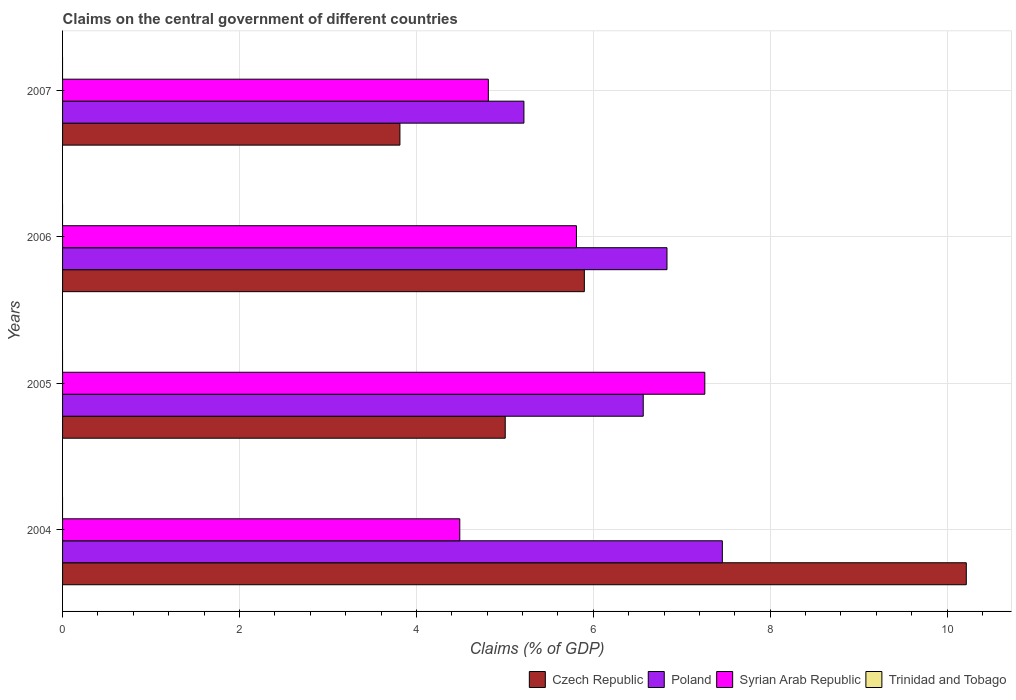How many different coloured bars are there?
Ensure brevity in your answer.  3. What is the label of the 2nd group of bars from the top?
Your answer should be compact. 2006. In how many cases, is the number of bars for a given year not equal to the number of legend labels?
Provide a short and direct response. 4. What is the percentage of GDP claimed on the central government in Trinidad and Tobago in 2007?
Ensure brevity in your answer.  0. Across all years, what is the maximum percentage of GDP claimed on the central government in Poland?
Your response must be concise. 7.46. Across all years, what is the minimum percentage of GDP claimed on the central government in Syrian Arab Republic?
Give a very brief answer. 4.49. In which year was the percentage of GDP claimed on the central government in Syrian Arab Republic maximum?
Make the answer very short. 2005. What is the total percentage of GDP claimed on the central government in Poland in the graph?
Ensure brevity in your answer.  26.07. What is the difference between the percentage of GDP claimed on the central government in Syrian Arab Republic in 2006 and that in 2007?
Offer a terse response. 1. What is the difference between the percentage of GDP claimed on the central government in Syrian Arab Republic in 2005 and the percentage of GDP claimed on the central government in Poland in 2007?
Give a very brief answer. 2.04. What is the average percentage of GDP claimed on the central government in Syrian Arab Republic per year?
Offer a very short reply. 5.59. In the year 2005, what is the difference between the percentage of GDP claimed on the central government in Czech Republic and percentage of GDP claimed on the central government in Syrian Arab Republic?
Keep it short and to the point. -2.26. In how many years, is the percentage of GDP claimed on the central government in Trinidad and Tobago greater than 9.2 %?
Your response must be concise. 0. What is the ratio of the percentage of GDP claimed on the central government in Czech Republic in 2005 to that in 2007?
Your response must be concise. 1.31. Is the percentage of GDP claimed on the central government in Poland in 2006 less than that in 2007?
Offer a terse response. No. Is the difference between the percentage of GDP claimed on the central government in Czech Republic in 2004 and 2005 greater than the difference between the percentage of GDP claimed on the central government in Syrian Arab Republic in 2004 and 2005?
Your answer should be very brief. Yes. What is the difference between the highest and the second highest percentage of GDP claimed on the central government in Czech Republic?
Your answer should be very brief. 4.32. What is the difference between the highest and the lowest percentage of GDP claimed on the central government in Syrian Arab Republic?
Your answer should be very brief. 2.77. In how many years, is the percentage of GDP claimed on the central government in Trinidad and Tobago greater than the average percentage of GDP claimed on the central government in Trinidad and Tobago taken over all years?
Offer a very short reply. 0. Is the sum of the percentage of GDP claimed on the central government in Syrian Arab Republic in 2005 and 2007 greater than the maximum percentage of GDP claimed on the central government in Trinidad and Tobago across all years?
Offer a terse response. Yes. Is it the case that in every year, the sum of the percentage of GDP claimed on the central government in Poland and percentage of GDP claimed on the central government in Syrian Arab Republic is greater than the sum of percentage of GDP claimed on the central government in Czech Republic and percentage of GDP claimed on the central government in Trinidad and Tobago?
Provide a short and direct response. No. Is it the case that in every year, the sum of the percentage of GDP claimed on the central government in Czech Republic and percentage of GDP claimed on the central government in Trinidad and Tobago is greater than the percentage of GDP claimed on the central government in Syrian Arab Republic?
Provide a succinct answer. No. How many bars are there?
Your answer should be very brief. 12. Are the values on the major ticks of X-axis written in scientific E-notation?
Ensure brevity in your answer.  No. Where does the legend appear in the graph?
Offer a very short reply. Bottom right. How many legend labels are there?
Offer a terse response. 4. How are the legend labels stacked?
Ensure brevity in your answer.  Horizontal. What is the title of the graph?
Make the answer very short. Claims on the central government of different countries. What is the label or title of the X-axis?
Provide a short and direct response. Claims (% of GDP). What is the Claims (% of GDP) of Czech Republic in 2004?
Your answer should be compact. 10.22. What is the Claims (% of GDP) of Poland in 2004?
Your answer should be very brief. 7.46. What is the Claims (% of GDP) in Syrian Arab Republic in 2004?
Your answer should be very brief. 4.49. What is the Claims (% of GDP) of Czech Republic in 2005?
Keep it short and to the point. 5. What is the Claims (% of GDP) of Poland in 2005?
Make the answer very short. 6.56. What is the Claims (% of GDP) of Syrian Arab Republic in 2005?
Make the answer very short. 7.26. What is the Claims (% of GDP) in Czech Republic in 2006?
Provide a short and direct response. 5.9. What is the Claims (% of GDP) in Poland in 2006?
Keep it short and to the point. 6.83. What is the Claims (% of GDP) in Syrian Arab Republic in 2006?
Your response must be concise. 5.81. What is the Claims (% of GDP) in Czech Republic in 2007?
Keep it short and to the point. 3.81. What is the Claims (% of GDP) in Poland in 2007?
Provide a succinct answer. 5.22. What is the Claims (% of GDP) of Syrian Arab Republic in 2007?
Your answer should be compact. 4.81. What is the Claims (% of GDP) of Trinidad and Tobago in 2007?
Your answer should be compact. 0. Across all years, what is the maximum Claims (% of GDP) of Czech Republic?
Make the answer very short. 10.22. Across all years, what is the maximum Claims (% of GDP) of Poland?
Offer a terse response. 7.46. Across all years, what is the maximum Claims (% of GDP) in Syrian Arab Republic?
Keep it short and to the point. 7.26. Across all years, what is the minimum Claims (% of GDP) of Czech Republic?
Offer a very short reply. 3.81. Across all years, what is the minimum Claims (% of GDP) of Poland?
Your answer should be very brief. 5.22. Across all years, what is the minimum Claims (% of GDP) in Syrian Arab Republic?
Offer a very short reply. 4.49. What is the total Claims (% of GDP) of Czech Republic in the graph?
Your answer should be compact. 24.93. What is the total Claims (% of GDP) in Poland in the graph?
Your answer should be compact. 26.07. What is the total Claims (% of GDP) in Syrian Arab Republic in the graph?
Provide a short and direct response. 22.37. What is the difference between the Claims (% of GDP) of Czech Republic in 2004 and that in 2005?
Your answer should be compact. 5.21. What is the difference between the Claims (% of GDP) of Poland in 2004 and that in 2005?
Provide a succinct answer. 0.89. What is the difference between the Claims (% of GDP) in Syrian Arab Republic in 2004 and that in 2005?
Offer a very short reply. -2.77. What is the difference between the Claims (% of GDP) in Czech Republic in 2004 and that in 2006?
Make the answer very short. 4.32. What is the difference between the Claims (% of GDP) in Poland in 2004 and that in 2006?
Offer a terse response. 0.63. What is the difference between the Claims (% of GDP) of Syrian Arab Republic in 2004 and that in 2006?
Make the answer very short. -1.32. What is the difference between the Claims (% of GDP) in Czech Republic in 2004 and that in 2007?
Provide a short and direct response. 6.4. What is the difference between the Claims (% of GDP) in Poland in 2004 and that in 2007?
Your answer should be very brief. 2.24. What is the difference between the Claims (% of GDP) in Syrian Arab Republic in 2004 and that in 2007?
Provide a short and direct response. -0.32. What is the difference between the Claims (% of GDP) of Czech Republic in 2005 and that in 2006?
Offer a terse response. -0.89. What is the difference between the Claims (% of GDP) in Poland in 2005 and that in 2006?
Keep it short and to the point. -0.27. What is the difference between the Claims (% of GDP) in Syrian Arab Republic in 2005 and that in 2006?
Ensure brevity in your answer.  1.45. What is the difference between the Claims (% of GDP) of Czech Republic in 2005 and that in 2007?
Make the answer very short. 1.19. What is the difference between the Claims (% of GDP) in Poland in 2005 and that in 2007?
Offer a very short reply. 1.35. What is the difference between the Claims (% of GDP) of Syrian Arab Republic in 2005 and that in 2007?
Make the answer very short. 2.45. What is the difference between the Claims (% of GDP) of Czech Republic in 2006 and that in 2007?
Offer a terse response. 2.08. What is the difference between the Claims (% of GDP) in Poland in 2006 and that in 2007?
Your answer should be compact. 1.62. What is the difference between the Claims (% of GDP) in Czech Republic in 2004 and the Claims (% of GDP) in Poland in 2005?
Your response must be concise. 3.65. What is the difference between the Claims (% of GDP) of Czech Republic in 2004 and the Claims (% of GDP) of Syrian Arab Republic in 2005?
Your answer should be very brief. 2.96. What is the difference between the Claims (% of GDP) in Poland in 2004 and the Claims (% of GDP) in Syrian Arab Republic in 2005?
Keep it short and to the point. 0.2. What is the difference between the Claims (% of GDP) of Czech Republic in 2004 and the Claims (% of GDP) of Poland in 2006?
Provide a short and direct response. 3.38. What is the difference between the Claims (% of GDP) in Czech Republic in 2004 and the Claims (% of GDP) in Syrian Arab Republic in 2006?
Keep it short and to the point. 4.41. What is the difference between the Claims (% of GDP) in Poland in 2004 and the Claims (% of GDP) in Syrian Arab Republic in 2006?
Ensure brevity in your answer.  1.65. What is the difference between the Claims (% of GDP) in Czech Republic in 2004 and the Claims (% of GDP) in Poland in 2007?
Make the answer very short. 5. What is the difference between the Claims (% of GDP) in Czech Republic in 2004 and the Claims (% of GDP) in Syrian Arab Republic in 2007?
Your answer should be compact. 5.4. What is the difference between the Claims (% of GDP) in Poland in 2004 and the Claims (% of GDP) in Syrian Arab Republic in 2007?
Make the answer very short. 2.65. What is the difference between the Claims (% of GDP) in Czech Republic in 2005 and the Claims (% of GDP) in Poland in 2006?
Offer a terse response. -1.83. What is the difference between the Claims (% of GDP) of Czech Republic in 2005 and the Claims (% of GDP) of Syrian Arab Republic in 2006?
Your answer should be compact. -0.81. What is the difference between the Claims (% of GDP) in Poland in 2005 and the Claims (% of GDP) in Syrian Arab Republic in 2006?
Ensure brevity in your answer.  0.76. What is the difference between the Claims (% of GDP) in Czech Republic in 2005 and the Claims (% of GDP) in Poland in 2007?
Give a very brief answer. -0.21. What is the difference between the Claims (% of GDP) in Czech Republic in 2005 and the Claims (% of GDP) in Syrian Arab Republic in 2007?
Make the answer very short. 0.19. What is the difference between the Claims (% of GDP) in Poland in 2005 and the Claims (% of GDP) in Syrian Arab Republic in 2007?
Ensure brevity in your answer.  1.75. What is the difference between the Claims (% of GDP) in Czech Republic in 2006 and the Claims (% of GDP) in Poland in 2007?
Your answer should be compact. 0.68. What is the difference between the Claims (% of GDP) of Czech Republic in 2006 and the Claims (% of GDP) of Syrian Arab Republic in 2007?
Offer a very short reply. 1.09. What is the difference between the Claims (% of GDP) of Poland in 2006 and the Claims (% of GDP) of Syrian Arab Republic in 2007?
Offer a very short reply. 2.02. What is the average Claims (% of GDP) of Czech Republic per year?
Your answer should be compact. 6.23. What is the average Claims (% of GDP) of Poland per year?
Offer a terse response. 6.52. What is the average Claims (% of GDP) of Syrian Arab Republic per year?
Your answer should be compact. 5.59. In the year 2004, what is the difference between the Claims (% of GDP) of Czech Republic and Claims (% of GDP) of Poland?
Your answer should be very brief. 2.76. In the year 2004, what is the difference between the Claims (% of GDP) in Czech Republic and Claims (% of GDP) in Syrian Arab Republic?
Ensure brevity in your answer.  5.73. In the year 2004, what is the difference between the Claims (% of GDP) of Poland and Claims (% of GDP) of Syrian Arab Republic?
Provide a short and direct response. 2.97. In the year 2005, what is the difference between the Claims (% of GDP) of Czech Republic and Claims (% of GDP) of Poland?
Offer a terse response. -1.56. In the year 2005, what is the difference between the Claims (% of GDP) of Czech Republic and Claims (% of GDP) of Syrian Arab Republic?
Make the answer very short. -2.26. In the year 2005, what is the difference between the Claims (% of GDP) of Poland and Claims (% of GDP) of Syrian Arab Republic?
Ensure brevity in your answer.  -0.7. In the year 2006, what is the difference between the Claims (% of GDP) of Czech Republic and Claims (% of GDP) of Poland?
Provide a short and direct response. -0.93. In the year 2006, what is the difference between the Claims (% of GDP) in Czech Republic and Claims (% of GDP) in Syrian Arab Republic?
Provide a short and direct response. 0.09. In the year 2006, what is the difference between the Claims (% of GDP) of Poland and Claims (% of GDP) of Syrian Arab Republic?
Give a very brief answer. 1.02. In the year 2007, what is the difference between the Claims (% of GDP) in Czech Republic and Claims (% of GDP) in Poland?
Provide a short and direct response. -1.4. In the year 2007, what is the difference between the Claims (% of GDP) in Czech Republic and Claims (% of GDP) in Syrian Arab Republic?
Make the answer very short. -1. In the year 2007, what is the difference between the Claims (% of GDP) of Poland and Claims (% of GDP) of Syrian Arab Republic?
Give a very brief answer. 0.4. What is the ratio of the Claims (% of GDP) of Czech Republic in 2004 to that in 2005?
Keep it short and to the point. 2.04. What is the ratio of the Claims (% of GDP) in Poland in 2004 to that in 2005?
Your answer should be compact. 1.14. What is the ratio of the Claims (% of GDP) in Syrian Arab Republic in 2004 to that in 2005?
Keep it short and to the point. 0.62. What is the ratio of the Claims (% of GDP) in Czech Republic in 2004 to that in 2006?
Your answer should be compact. 1.73. What is the ratio of the Claims (% of GDP) in Poland in 2004 to that in 2006?
Your response must be concise. 1.09. What is the ratio of the Claims (% of GDP) of Syrian Arab Republic in 2004 to that in 2006?
Offer a very short reply. 0.77. What is the ratio of the Claims (% of GDP) in Czech Republic in 2004 to that in 2007?
Your response must be concise. 2.68. What is the ratio of the Claims (% of GDP) of Poland in 2004 to that in 2007?
Your answer should be compact. 1.43. What is the ratio of the Claims (% of GDP) of Syrian Arab Republic in 2004 to that in 2007?
Ensure brevity in your answer.  0.93. What is the ratio of the Claims (% of GDP) in Czech Republic in 2005 to that in 2006?
Provide a short and direct response. 0.85. What is the ratio of the Claims (% of GDP) of Poland in 2005 to that in 2006?
Make the answer very short. 0.96. What is the ratio of the Claims (% of GDP) in Syrian Arab Republic in 2005 to that in 2006?
Give a very brief answer. 1.25. What is the ratio of the Claims (% of GDP) in Czech Republic in 2005 to that in 2007?
Offer a terse response. 1.31. What is the ratio of the Claims (% of GDP) of Poland in 2005 to that in 2007?
Your response must be concise. 1.26. What is the ratio of the Claims (% of GDP) in Syrian Arab Republic in 2005 to that in 2007?
Your answer should be very brief. 1.51. What is the ratio of the Claims (% of GDP) of Czech Republic in 2006 to that in 2007?
Keep it short and to the point. 1.55. What is the ratio of the Claims (% of GDP) of Poland in 2006 to that in 2007?
Ensure brevity in your answer.  1.31. What is the ratio of the Claims (% of GDP) of Syrian Arab Republic in 2006 to that in 2007?
Ensure brevity in your answer.  1.21. What is the difference between the highest and the second highest Claims (% of GDP) of Czech Republic?
Your response must be concise. 4.32. What is the difference between the highest and the second highest Claims (% of GDP) of Poland?
Your answer should be very brief. 0.63. What is the difference between the highest and the second highest Claims (% of GDP) of Syrian Arab Republic?
Give a very brief answer. 1.45. What is the difference between the highest and the lowest Claims (% of GDP) in Czech Republic?
Offer a terse response. 6.4. What is the difference between the highest and the lowest Claims (% of GDP) in Poland?
Keep it short and to the point. 2.24. What is the difference between the highest and the lowest Claims (% of GDP) in Syrian Arab Republic?
Offer a very short reply. 2.77. 